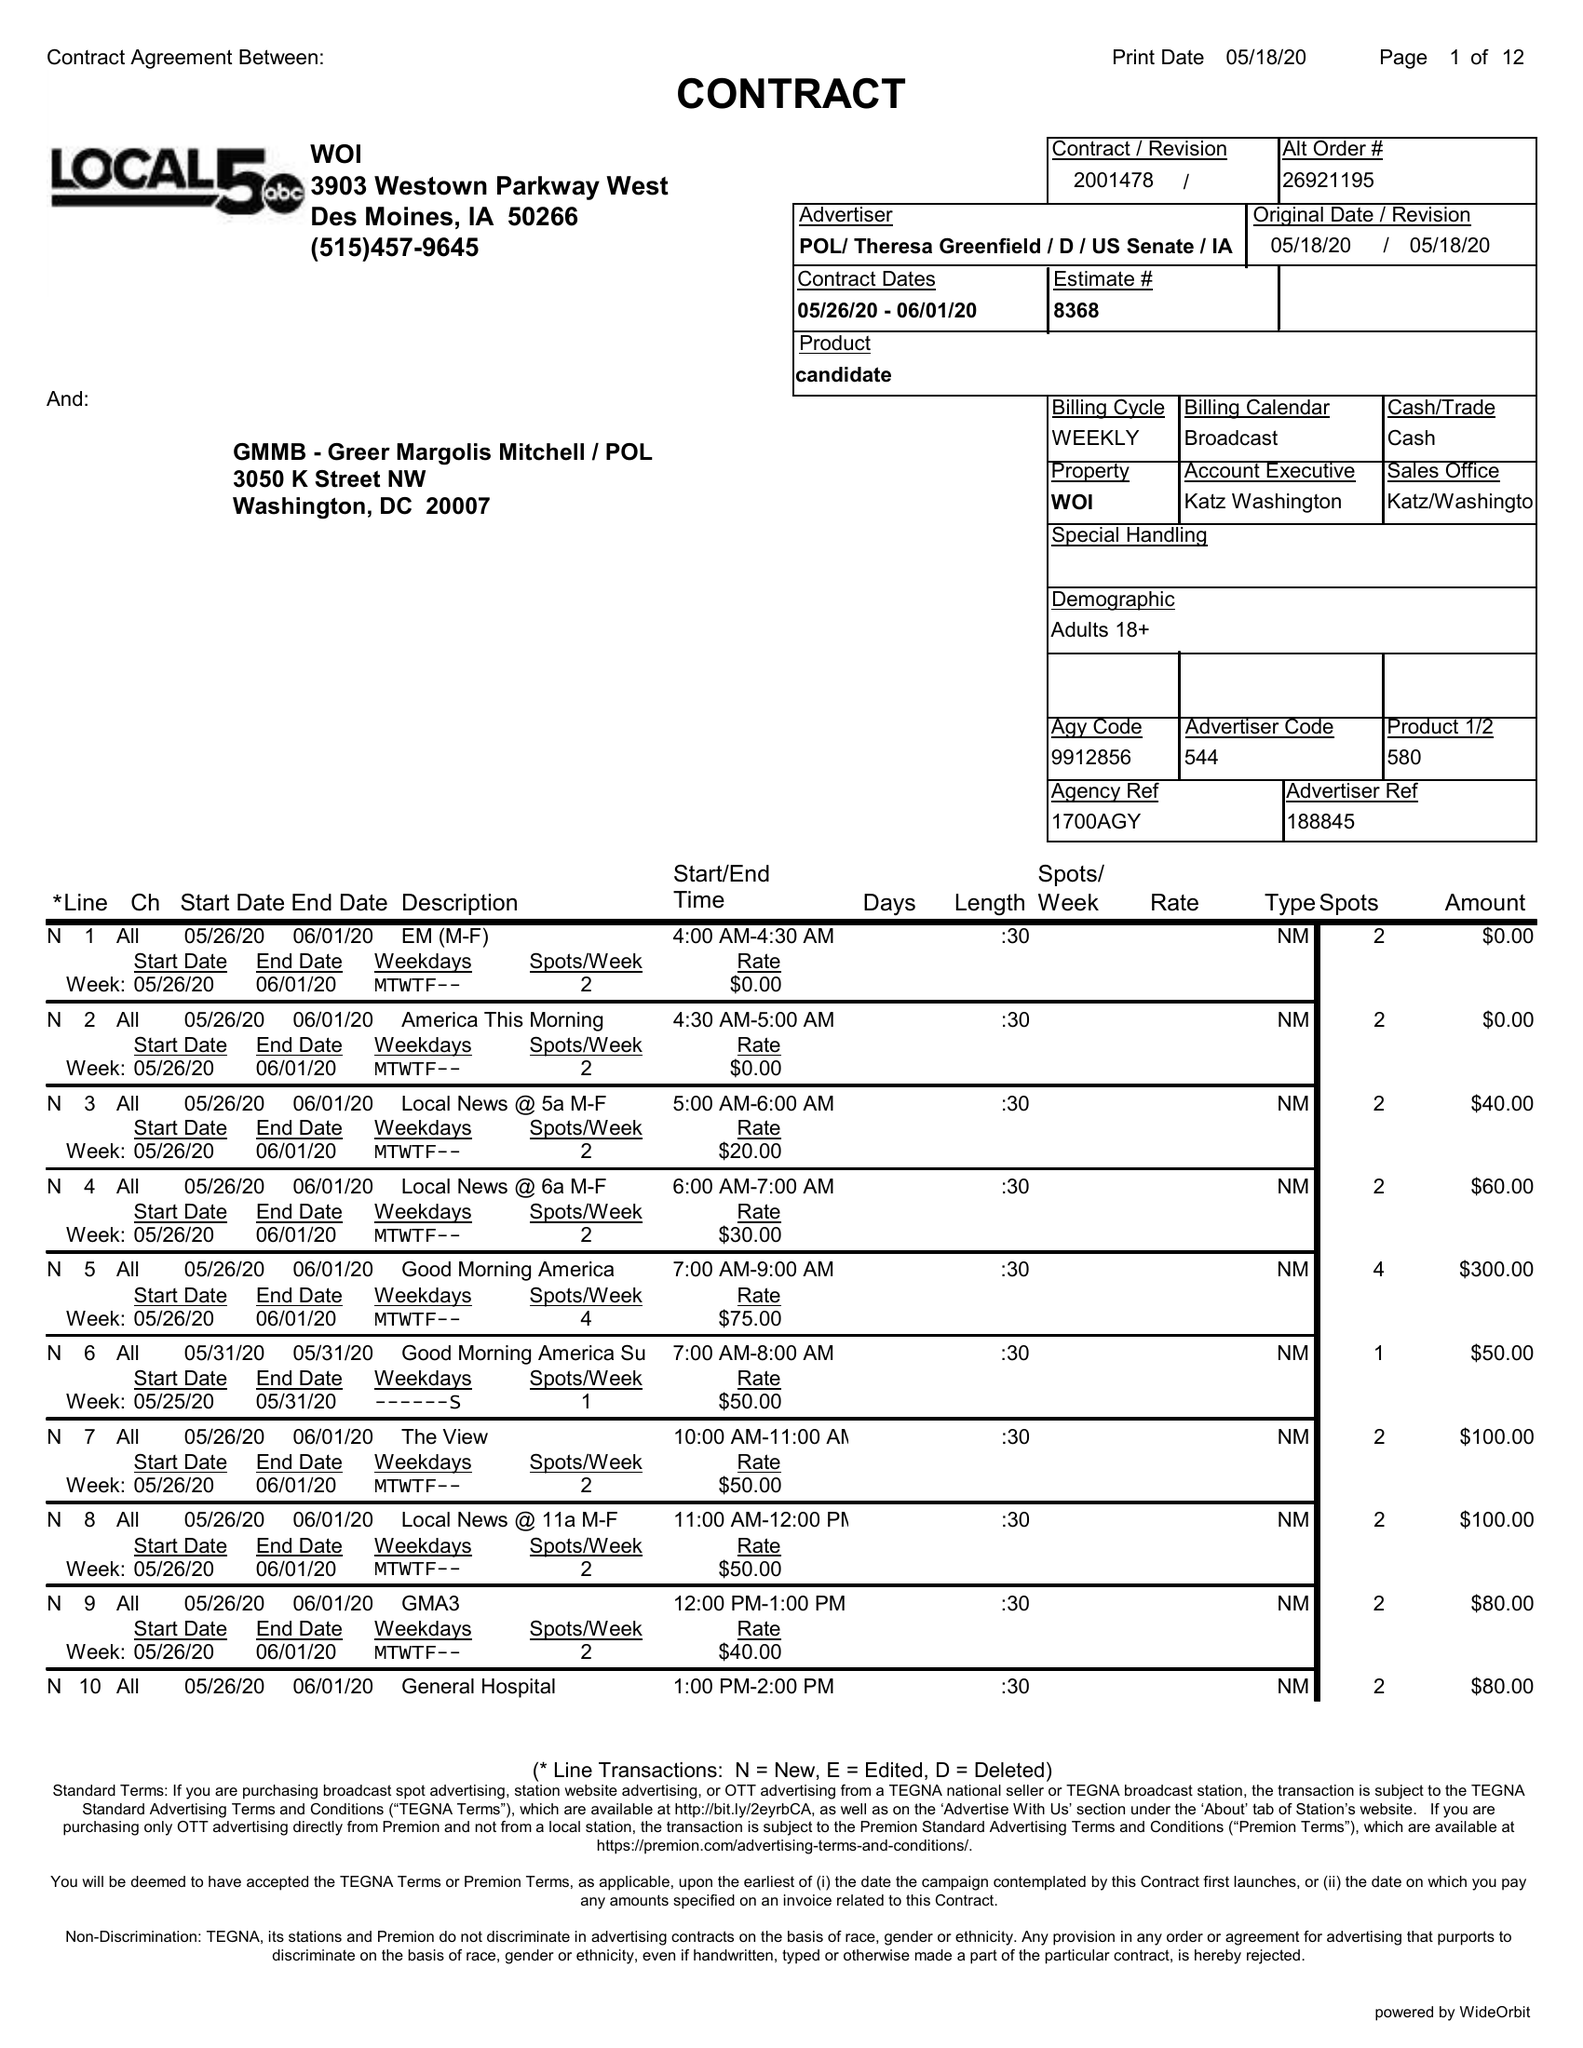What is the value for the advertiser?
Answer the question using a single word or phrase. POL/THERESAGREENFIELD/D/USSENATE/IA 